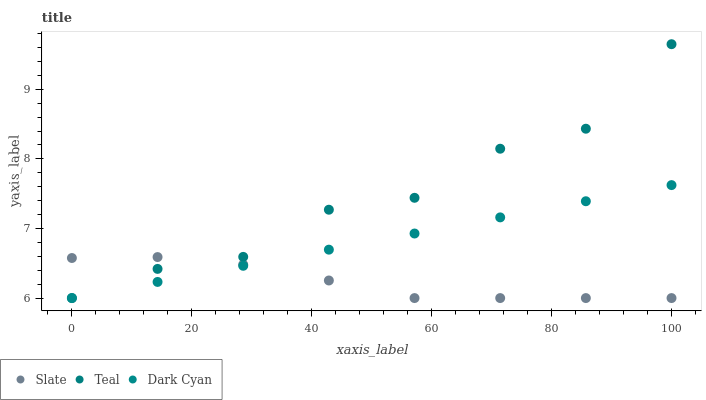Does Slate have the minimum area under the curve?
Answer yes or no. Yes. Does Teal have the maximum area under the curve?
Answer yes or no. Yes. Does Teal have the minimum area under the curve?
Answer yes or no. No. Does Slate have the maximum area under the curve?
Answer yes or no. No. Is Dark Cyan the smoothest?
Answer yes or no. Yes. Is Teal the roughest?
Answer yes or no. Yes. Is Slate the smoothest?
Answer yes or no. No. Is Slate the roughest?
Answer yes or no. No. Does Dark Cyan have the lowest value?
Answer yes or no. Yes. Does Teal have the highest value?
Answer yes or no. Yes. Does Slate have the highest value?
Answer yes or no. No. Does Teal intersect Dark Cyan?
Answer yes or no. Yes. Is Teal less than Dark Cyan?
Answer yes or no. No. Is Teal greater than Dark Cyan?
Answer yes or no. No. 